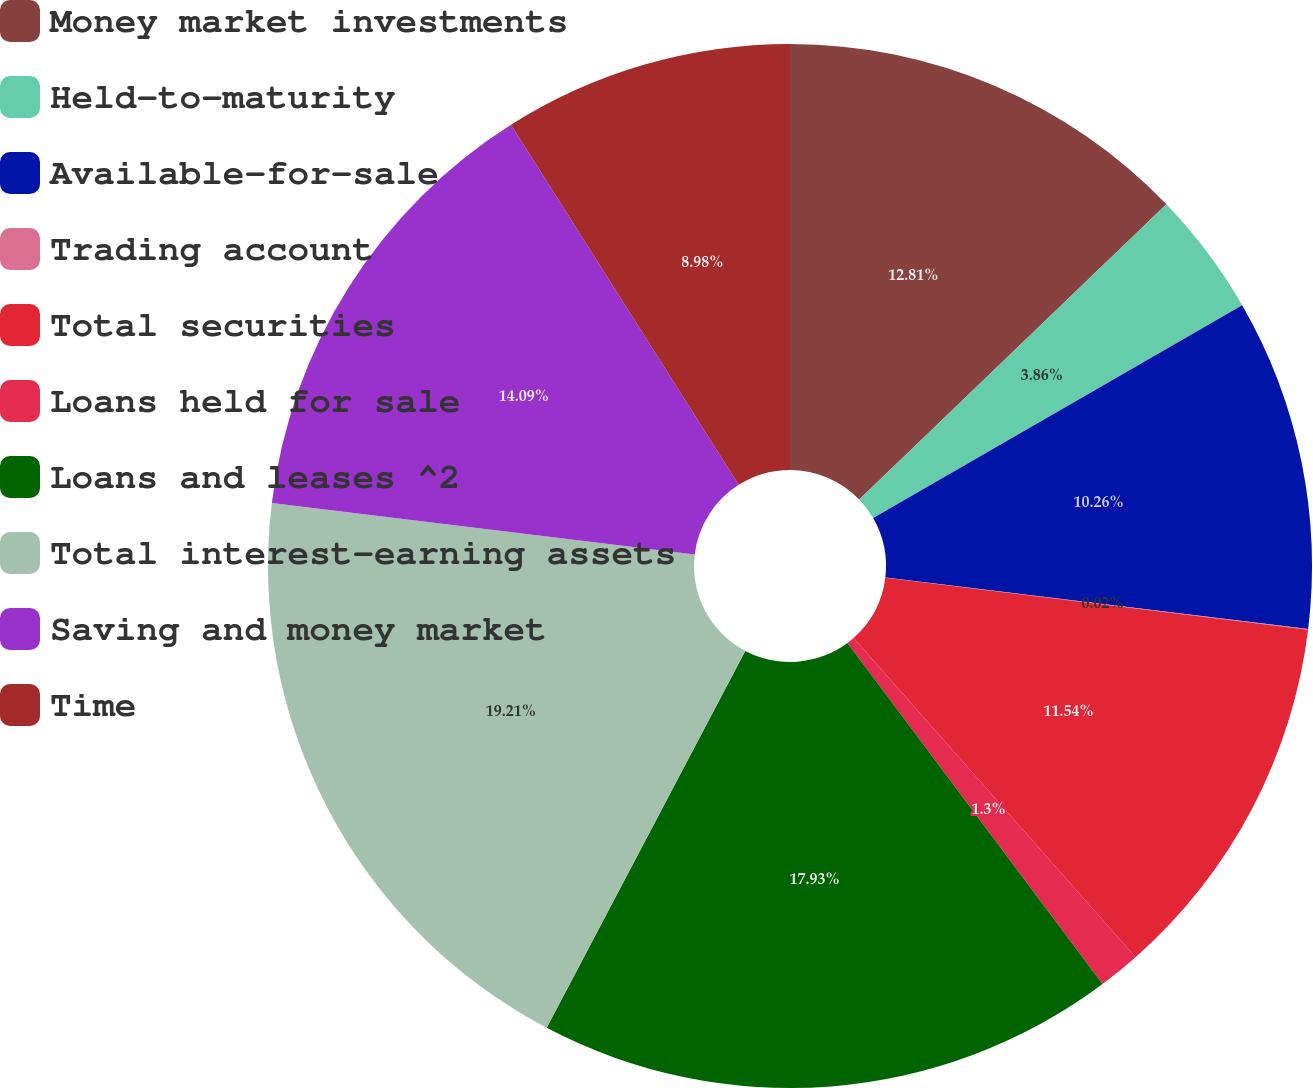Convert chart. <chart><loc_0><loc_0><loc_500><loc_500><pie_chart><fcel>Money market investments<fcel>Held-to-maturity<fcel>Available-for-sale<fcel>Trading account<fcel>Total securities<fcel>Loans held for sale<fcel>Loans and leases ^2<fcel>Total interest-earning assets<fcel>Saving and money market<fcel>Time<nl><fcel>12.82%<fcel>3.86%<fcel>10.26%<fcel>0.02%<fcel>11.54%<fcel>1.3%<fcel>17.94%<fcel>19.22%<fcel>14.1%<fcel>8.98%<nl></chart> 